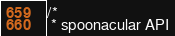<code> <loc_0><loc_0><loc_500><loc_500><_Java_>/*
 * spoonacular API</code> 